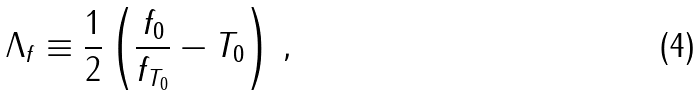Convert formula to latex. <formula><loc_0><loc_0><loc_500><loc_500>\Lambda _ { f } \equiv \frac { 1 } { 2 } \left ( \frac { f _ { 0 } } { f _ { T _ { 0 } } } - T _ { 0 } \right ) \, ,</formula> 